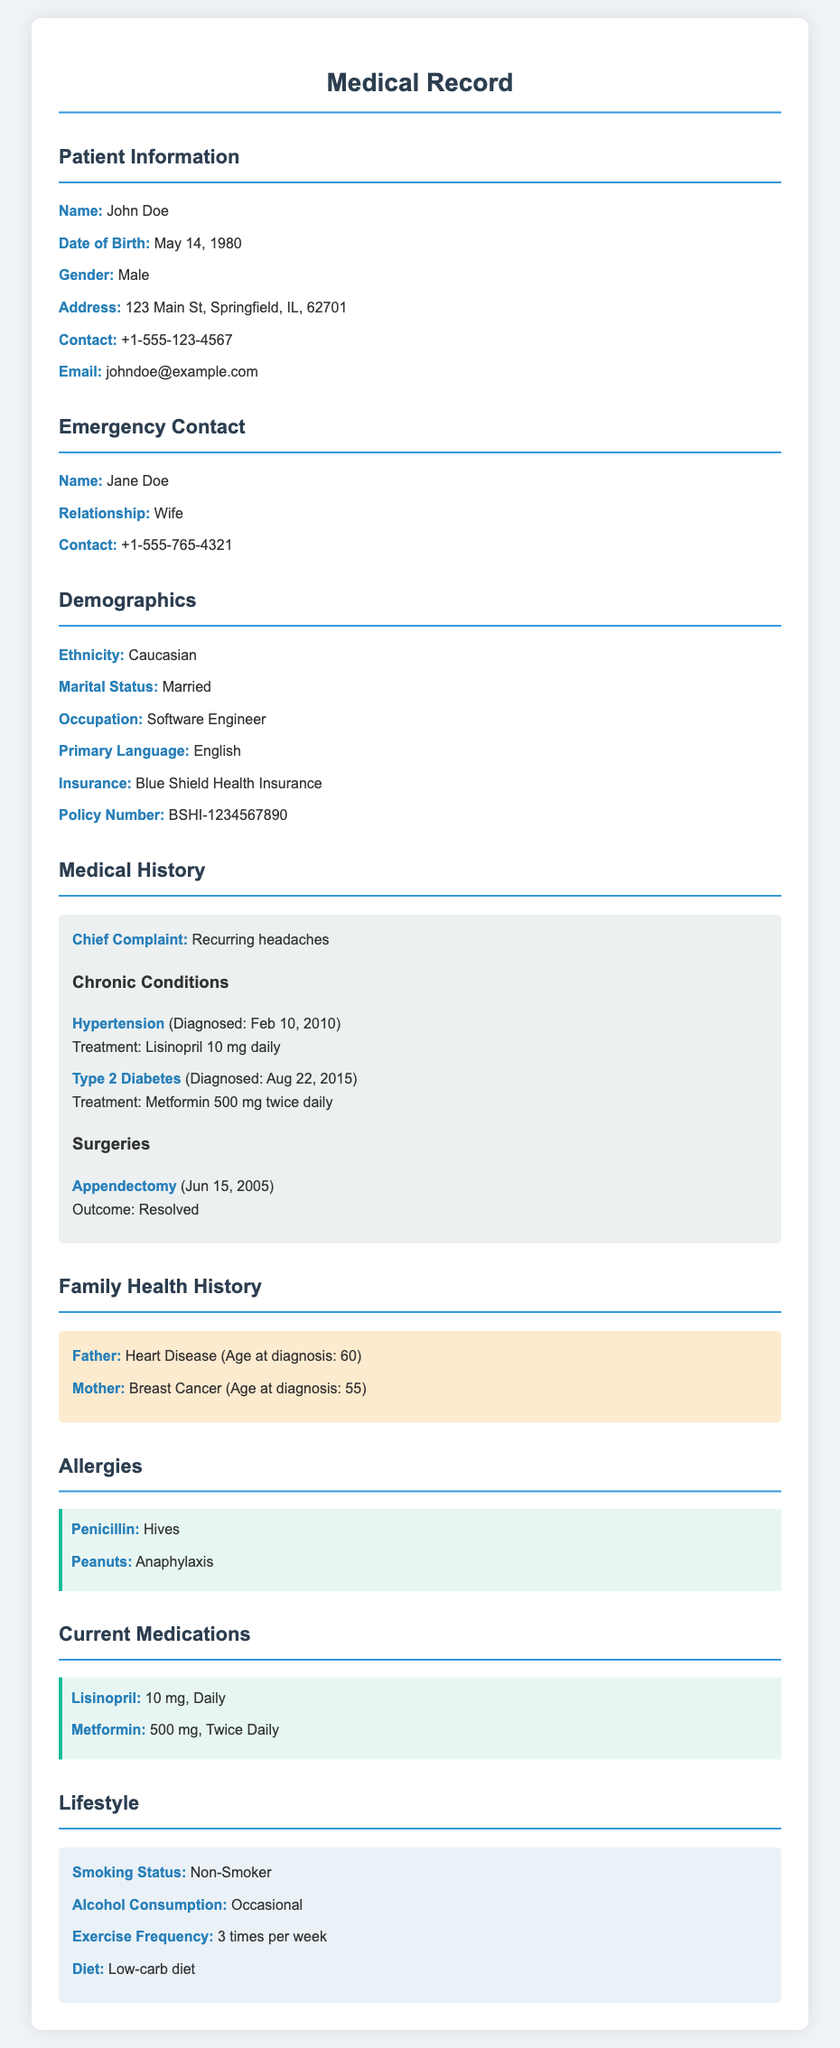What is the patient's name? The patient's name is listed under the Patient Information section.
Answer: John Doe What is the patient's date of birth? The date of birth is provided in the Patient Information section.
Answer: May 14, 1980 What is the primary language spoken by the patient? The primary language is specified in the Demographics section.
Answer: English What is the name of the patient's emergency contact? The name of the emergency contact is found in the Emergency Contact section.
Answer: Jane Doe What chronic condition was diagnosed on February 10, 2010? This information is found in the Medical History section under Chronic Conditions.
Answer: Hypertension What type of allergy does the patient have that results in anaphylaxis? This detail is listed in the Allergies section of the document.
Answer: Peanuts How many times per week does the patient exercise? The exercise frequency is covered in the Lifestyle section.
Answer: 3 times per week What is the patient's current medication for hypertension? The medication details can be found in the Current Medications section.
Answer: Lisinopril What family health condition does the patient's father have? This information is listed under the Family Health History section.
Answer: Heart Disease 